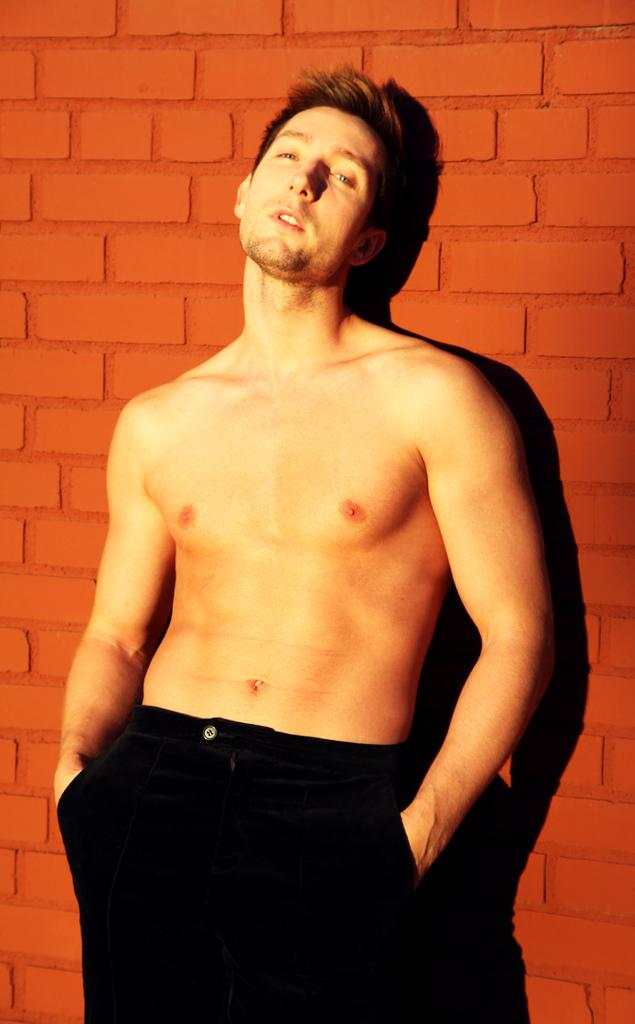Who is present in the image? There is a man in the image. What is the man doing in the image? The man is standing. What type of plantation can be seen in the background of the image? There is no plantation present in the image; it only features a man standing. 